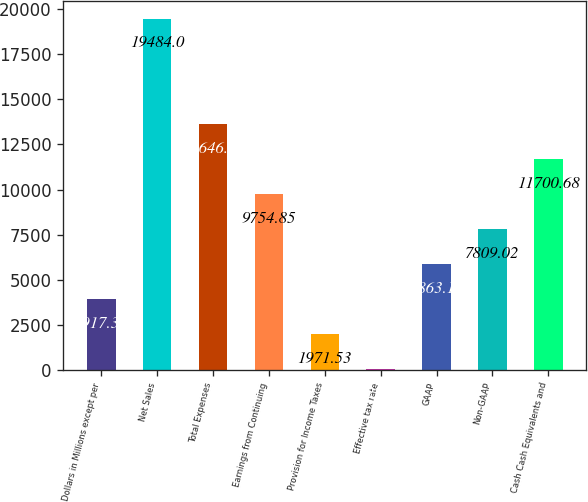<chart> <loc_0><loc_0><loc_500><loc_500><bar_chart><fcel>Dollars in Millions except per<fcel>Net Sales<fcel>Total Expenses<fcel>Earnings from Continuing<fcel>Provision for Income Taxes<fcel>Effective tax rate<fcel>GAAP<fcel>Non-GAAP<fcel>Cash Cash Equivalents and<nl><fcel>3917.36<fcel>19484<fcel>13646.5<fcel>9754.85<fcel>1971.53<fcel>25.7<fcel>5863.19<fcel>7809.02<fcel>11700.7<nl></chart> 